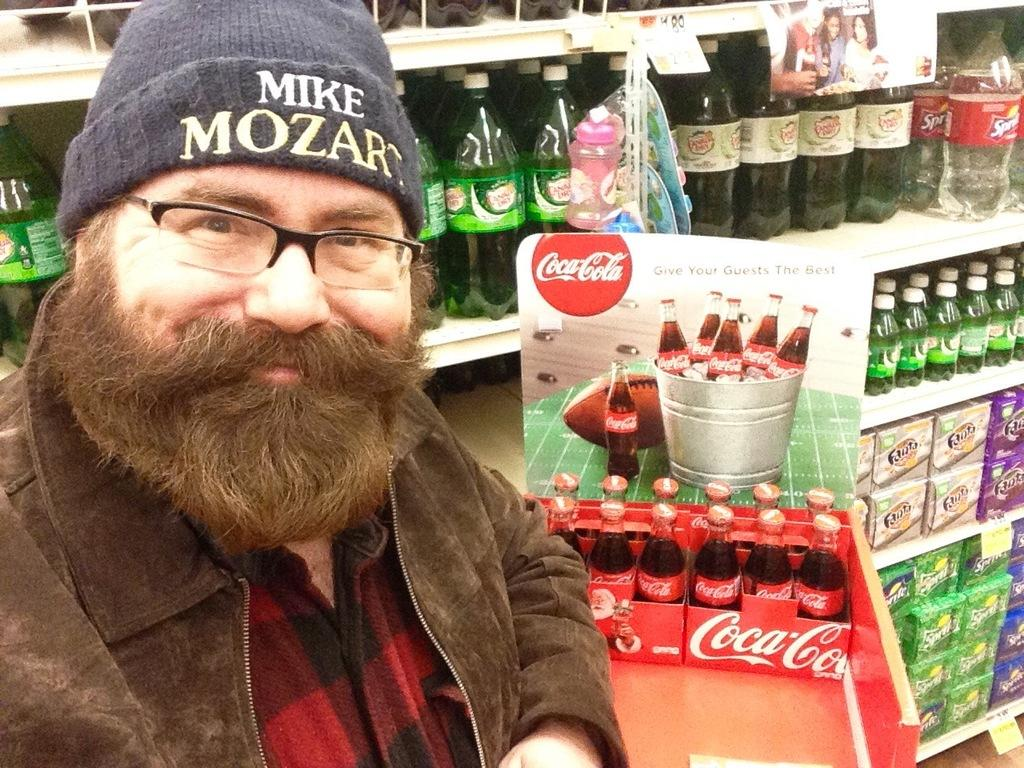Who is in the image? There is a man in the image. What is the man doing in the image? The man is smiling in the image. Where are the bottles located in the image? The bottles are located at the right side of the image. Can you describe the background of the image? There are additional bottles on a rack in the background of the image. What is the name of the farm where the man is standing in the image? There is no farm present in the image, and therefore no name can be given. 